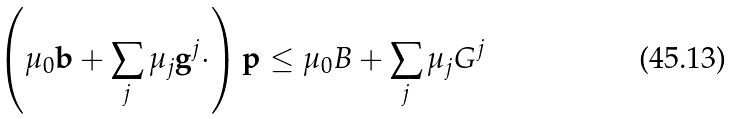<formula> <loc_0><loc_0><loc_500><loc_500>\left ( \mu _ { 0 } \mathbf b + \sum _ { j } \mu _ { j } \mathbf g ^ { j } \cdot \right ) \mathbf p \leq \mu _ { 0 } B + \sum _ { j } \mu _ { j } G ^ { j }</formula> 